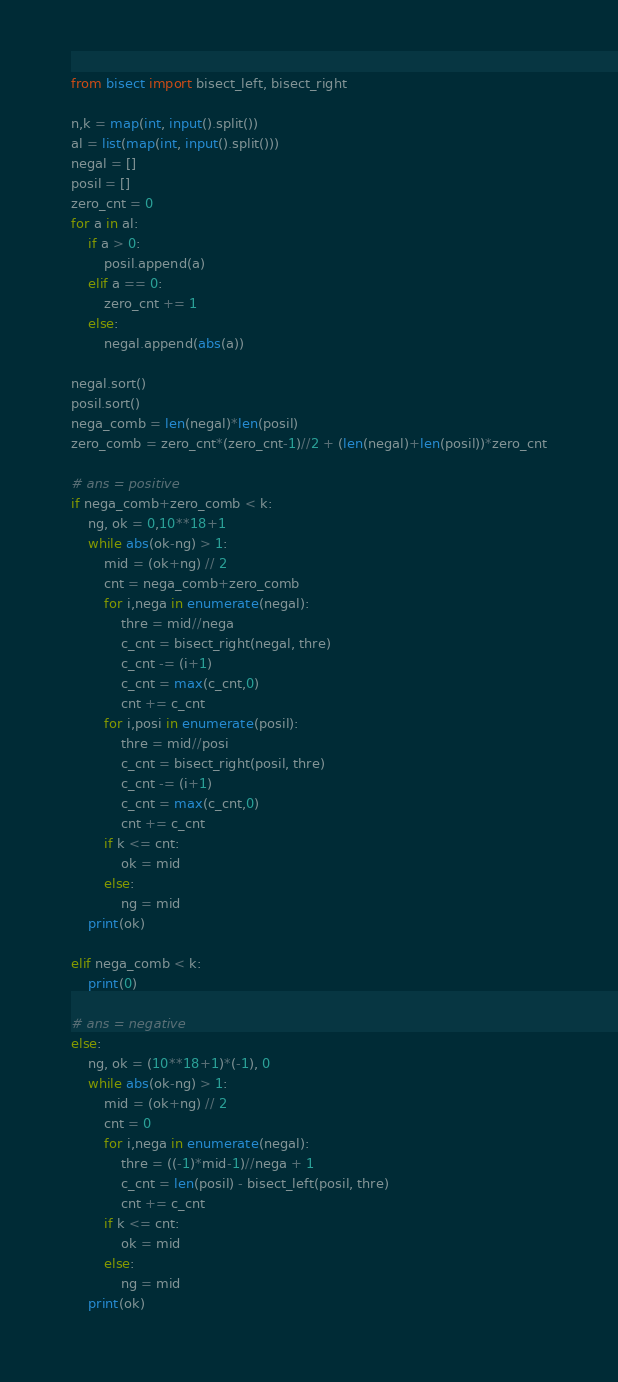<code> <loc_0><loc_0><loc_500><loc_500><_Python_>from bisect import bisect_left, bisect_right

n,k = map(int, input().split())
al = list(map(int, input().split()))
negal = []
posil = []
zero_cnt = 0
for a in al:
    if a > 0:
        posil.append(a)
    elif a == 0:
        zero_cnt += 1
    else:
        negal.append(abs(a))

negal.sort()
posil.sort()
nega_comb = len(negal)*len(posil)
zero_comb = zero_cnt*(zero_cnt-1)//2 + (len(negal)+len(posil))*zero_cnt

# ans = positive
if nega_comb+zero_comb < k:
    ng, ok = 0,10**18+1
    while abs(ok-ng) > 1:
        mid = (ok+ng) // 2
        cnt = nega_comb+zero_comb
        for i,nega in enumerate(negal):
            thre = mid//nega
            c_cnt = bisect_right(negal, thre)
            c_cnt -= (i+1)
            c_cnt = max(c_cnt,0)
            cnt += c_cnt
        for i,posi in enumerate(posil):
            thre = mid//posi
            c_cnt = bisect_right(posil, thre)
            c_cnt -= (i+1)
            c_cnt = max(c_cnt,0)
            cnt += c_cnt
        if k <= cnt:
            ok = mid
        else:
            ng = mid
    print(ok)

elif nega_comb < k:
    print(0)

# ans = negative
else:
    ng, ok = (10**18+1)*(-1), 0
    while abs(ok-ng) > 1:
        mid = (ok+ng) // 2
        cnt = 0
        for i,nega in enumerate(negal):
            thre = ((-1)*mid-1)//nega + 1
            c_cnt = len(posil) - bisect_left(posil, thre)
            cnt += c_cnt
        if k <= cnt:
            ok = mid
        else:
            ng = mid
    print(ok)</code> 